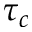<formula> <loc_0><loc_0><loc_500><loc_500>\tau _ { c }</formula> 